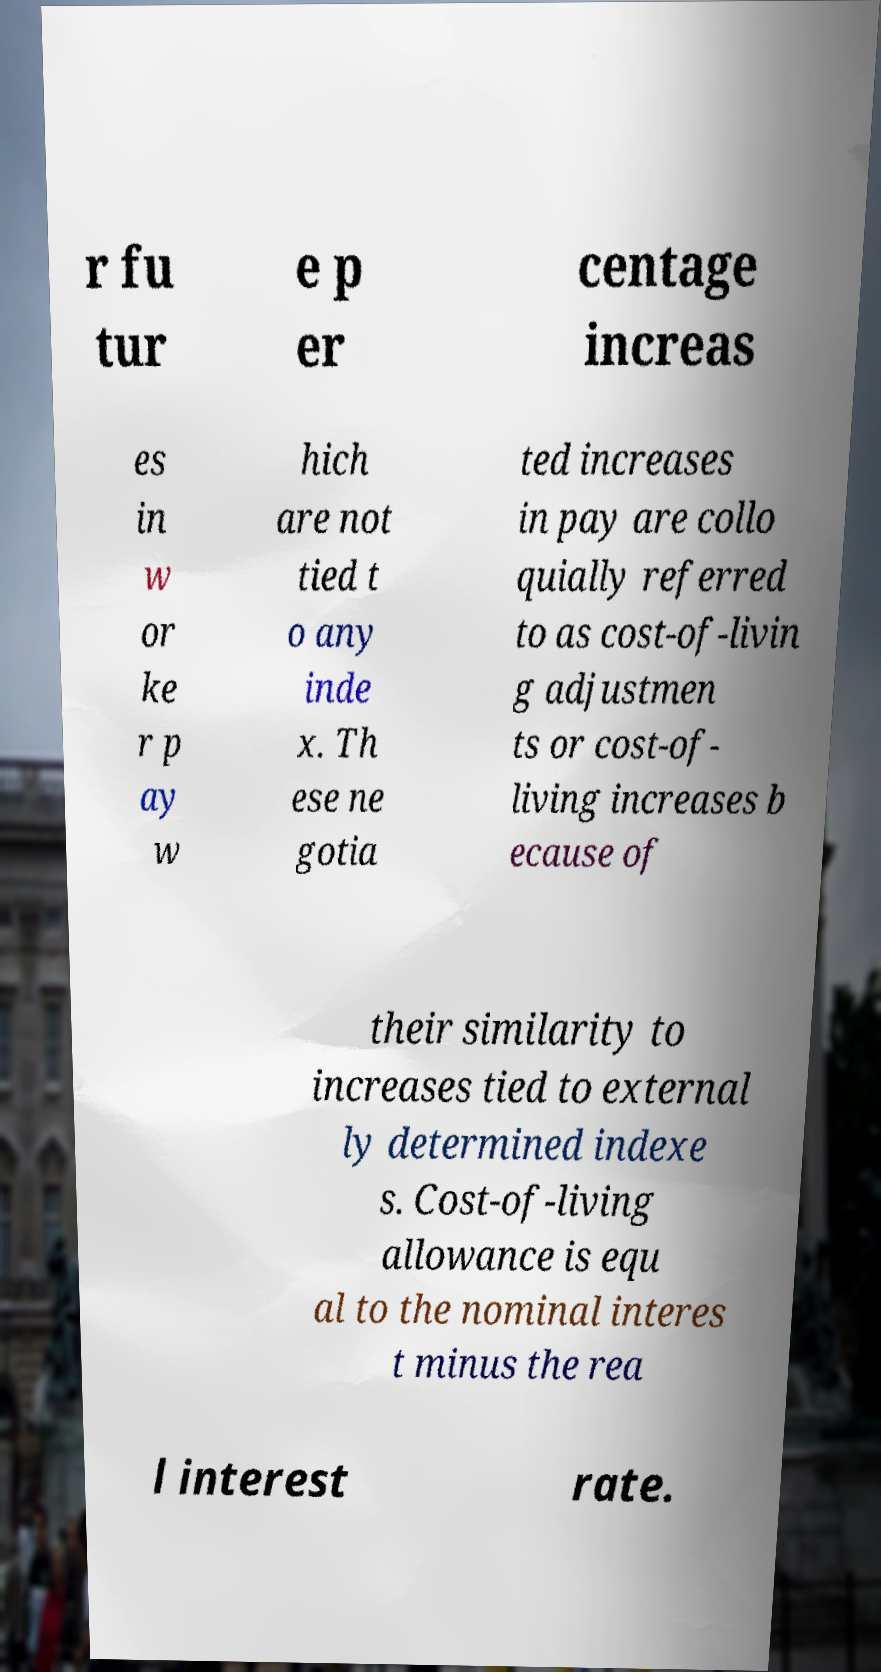Could you assist in decoding the text presented in this image and type it out clearly? r fu tur e p er centage increas es in w or ke r p ay w hich are not tied t o any inde x. Th ese ne gotia ted increases in pay are collo quially referred to as cost-of-livin g adjustmen ts or cost-of- living increases b ecause of their similarity to increases tied to external ly determined indexe s. Cost-of-living allowance is equ al to the nominal interes t minus the rea l interest rate. 